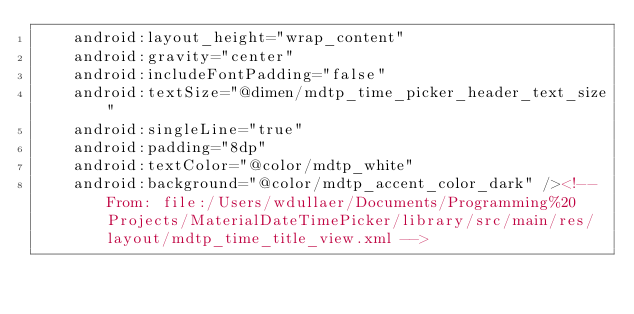<code> <loc_0><loc_0><loc_500><loc_500><_XML_>    android:layout_height="wrap_content"
    android:gravity="center"
    android:includeFontPadding="false"
    android:textSize="@dimen/mdtp_time_picker_header_text_size"
    android:singleLine="true"
    android:padding="8dp"
    android:textColor="@color/mdtp_white"
    android:background="@color/mdtp_accent_color_dark" /><!-- From: file:/Users/wdullaer/Documents/Programming%20Projects/MaterialDateTimePicker/library/src/main/res/layout/mdtp_time_title_view.xml --></code> 